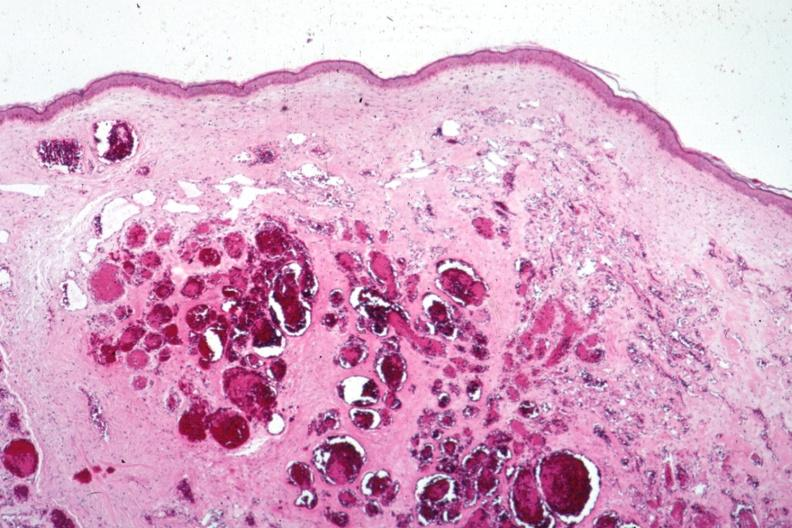s blood clot present?
Answer the question using a single word or phrase. No 